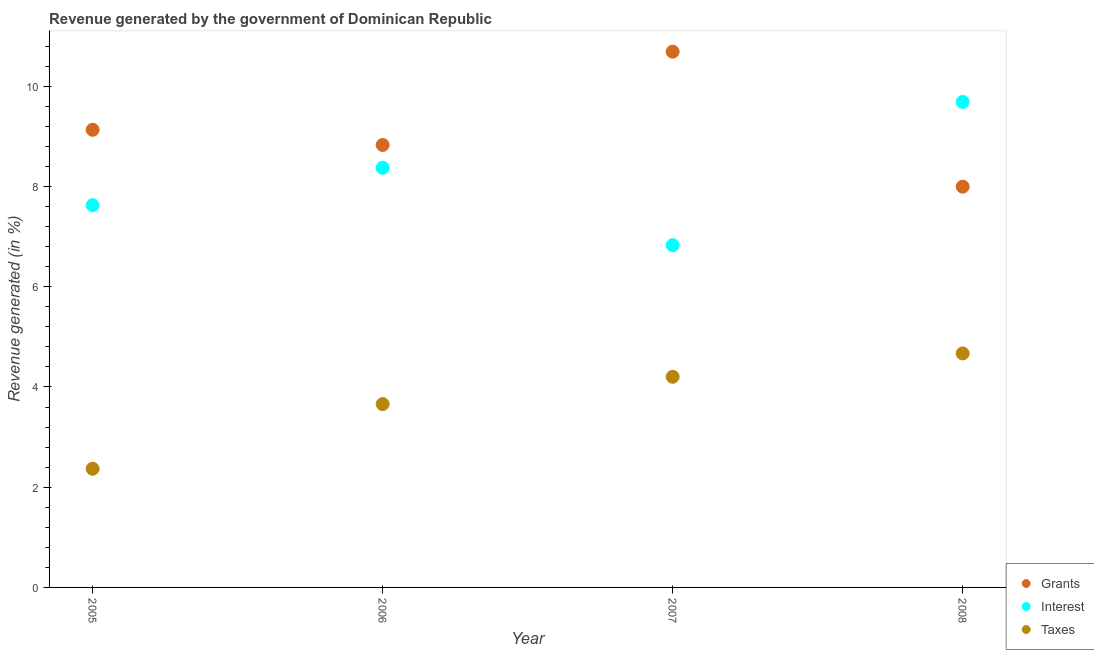How many different coloured dotlines are there?
Your answer should be compact. 3. What is the percentage of revenue generated by interest in 2005?
Provide a short and direct response. 7.63. Across all years, what is the maximum percentage of revenue generated by taxes?
Your response must be concise. 4.67. Across all years, what is the minimum percentage of revenue generated by taxes?
Your answer should be compact. 2.37. In which year was the percentage of revenue generated by grants maximum?
Your answer should be very brief. 2007. In which year was the percentage of revenue generated by taxes minimum?
Keep it short and to the point. 2005. What is the total percentage of revenue generated by taxes in the graph?
Keep it short and to the point. 14.9. What is the difference between the percentage of revenue generated by grants in 2007 and that in 2008?
Make the answer very short. 2.69. What is the difference between the percentage of revenue generated by interest in 2007 and the percentage of revenue generated by grants in 2008?
Make the answer very short. -1.17. What is the average percentage of revenue generated by grants per year?
Offer a very short reply. 9.16. In the year 2008, what is the difference between the percentage of revenue generated by grants and percentage of revenue generated by interest?
Provide a short and direct response. -1.69. In how many years, is the percentage of revenue generated by grants greater than 2.8 %?
Your response must be concise. 4. What is the ratio of the percentage of revenue generated by grants in 2005 to that in 2007?
Give a very brief answer. 0.85. What is the difference between the highest and the second highest percentage of revenue generated by taxes?
Make the answer very short. 0.47. What is the difference between the highest and the lowest percentage of revenue generated by grants?
Your answer should be compact. 2.69. Is the sum of the percentage of revenue generated by interest in 2007 and 2008 greater than the maximum percentage of revenue generated by grants across all years?
Provide a succinct answer. Yes. Is it the case that in every year, the sum of the percentage of revenue generated by grants and percentage of revenue generated by interest is greater than the percentage of revenue generated by taxes?
Ensure brevity in your answer.  Yes. Does the percentage of revenue generated by grants monotonically increase over the years?
Keep it short and to the point. No. Are the values on the major ticks of Y-axis written in scientific E-notation?
Offer a very short reply. No. How many legend labels are there?
Your response must be concise. 3. How are the legend labels stacked?
Offer a very short reply. Vertical. What is the title of the graph?
Your response must be concise. Revenue generated by the government of Dominican Republic. Does "Fuel" appear as one of the legend labels in the graph?
Keep it short and to the point. No. What is the label or title of the Y-axis?
Offer a very short reply. Revenue generated (in %). What is the Revenue generated (in %) of Grants in 2005?
Your response must be concise. 9.13. What is the Revenue generated (in %) in Interest in 2005?
Make the answer very short. 7.63. What is the Revenue generated (in %) of Taxes in 2005?
Offer a very short reply. 2.37. What is the Revenue generated (in %) of Grants in 2006?
Your answer should be compact. 8.83. What is the Revenue generated (in %) in Interest in 2006?
Provide a short and direct response. 8.37. What is the Revenue generated (in %) in Taxes in 2006?
Ensure brevity in your answer.  3.66. What is the Revenue generated (in %) in Grants in 2007?
Offer a terse response. 10.69. What is the Revenue generated (in %) of Interest in 2007?
Ensure brevity in your answer.  6.83. What is the Revenue generated (in %) of Taxes in 2007?
Offer a terse response. 4.2. What is the Revenue generated (in %) of Grants in 2008?
Provide a short and direct response. 8. What is the Revenue generated (in %) of Interest in 2008?
Your answer should be compact. 9.69. What is the Revenue generated (in %) in Taxes in 2008?
Your response must be concise. 4.67. Across all years, what is the maximum Revenue generated (in %) in Grants?
Make the answer very short. 10.69. Across all years, what is the maximum Revenue generated (in %) of Interest?
Your answer should be compact. 9.69. Across all years, what is the maximum Revenue generated (in %) in Taxes?
Give a very brief answer. 4.67. Across all years, what is the minimum Revenue generated (in %) of Grants?
Provide a succinct answer. 8. Across all years, what is the minimum Revenue generated (in %) of Interest?
Provide a succinct answer. 6.83. Across all years, what is the minimum Revenue generated (in %) of Taxes?
Offer a very short reply. 2.37. What is the total Revenue generated (in %) in Grants in the graph?
Your answer should be compact. 36.65. What is the total Revenue generated (in %) in Interest in the graph?
Your answer should be compact. 32.52. What is the total Revenue generated (in %) in Taxes in the graph?
Make the answer very short. 14.9. What is the difference between the Revenue generated (in %) of Grants in 2005 and that in 2006?
Offer a very short reply. 0.3. What is the difference between the Revenue generated (in %) of Interest in 2005 and that in 2006?
Ensure brevity in your answer.  -0.75. What is the difference between the Revenue generated (in %) of Taxes in 2005 and that in 2006?
Your response must be concise. -1.29. What is the difference between the Revenue generated (in %) in Grants in 2005 and that in 2007?
Offer a very short reply. -1.56. What is the difference between the Revenue generated (in %) in Interest in 2005 and that in 2007?
Ensure brevity in your answer.  0.8. What is the difference between the Revenue generated (in %) of Taxes in 2005 and that in 2007?
Give a very brief answer. -1.84. What is the difference between the Revenue generated (in %) in Grants in 2005 and that in 2008?
Make the answer very short. 1.14. What is the difference between the Revenue generated (in %) in Interest in 2005 and that in 2008?
Your answer should be very brief. -2.06. What is the difference between the Revenue generated (in %) of Taxes in 2005 and that in 2008?
Offer a very short reply. -2.3. What is the difference between the Revenue generated (in %) in Grants in 2006 and that in 2007?
Your answer should be compact. -1.86. What is the difference between the Revenue generated (in %) in Interest in 2006 and that in 2007?
Provide a succinct answer. 1.54. What is the difference between the Revenue generated (in %) of Taxes in 2006 and that in 2007?
Offer a terse response. -0.55. What is the difference between the Revenue generated (in %) in Grants in 2006 and that in 2008?
Ensure brevity in your answer.  0.83. What is the difference between the Revenue generated (in %) of Interest in 2006 and that in 2008?
Your response must be concise. -1.31. What is the difference between the Revenue generated (in %) in Taxes in 2006 and that in 2008?
Give a very brief answer. -1.01. What is the difference between the Revenue generated (in %) of Grants in 2007 and that in 2008?
Keep it short and to the point. 2.69. What is the difference between the Revenue generated (in %) of Interest in 2007 and that in 2008?
Provide a succinct answer. -2.86. What is the difference between the Revenue generated (in %) in Taxes in 2007 and that in 2008?
Offer a terse response. -0.47. What is the difference between the Revenue generated (in %) of Grants in 2005 and the Revenue generated (in %) of Interest in 2006?
Provide a succinct answer. 0.76. What is the difference between the Revenue generated (in %) of Grants in 2005 and the Revenue generated (in %) of Taxes in 2006?
Offer a terse response. 5.47. What is the difference between the Revenue generated (in %) in Interest in 2005 and the Revenue generated (in %) in Taxes in 2006?
Offer a very short reply. 3.97. What is the difference between the Revenue generated (in %) of Grants in 2005 and the Revenue generated (in %) of Interest in 2007?
Your answer should be compact. 2.3. What is the difference between the Revenue generated (in %) in Grants in 2005 and the Revenue generated (in %) in Taxes in 2007?
Give a very brief answer. 4.93. What is the difference between the Revenue generated (in %) of Interest in 2005 and the Revenue generated (in %) of Taxes in 2007?
Your answer should be very brief. 3.42. What is the difference between the Revenue generated (in %) in Grants in 2005 and the Revenue generated (in %) in Interest in 2008?
Your answer should be very brief. -0.56. What is the difference between the Revenue generated (in %) in Grants in 2005 and the Revenue generated (in %) in Taxes in 2008?
Your response must be concise. 4.46. What is the difference between the Revenue generated (in %) in Interest in 2005 and the Revenue generated (in %) in Taxes in 2008?
Your answer should be compact. 2.96. What is the difference between the Revenue generated (in %) in Grants in 2006 and the Revenue generated (in %) in Interest in 2007?
Give a very brief answer. 2. What is the difference between the Revenue generated (in %) in Grants in 2006 and the Revenue generated (in %) in Taxes in 2007?
Make the answer very short. 4.63. What is the difference between the Revenue generated (in %) of Interest in 2006 and the Revenue generated (in %) of Taxes in 2007?
Offer a very short reply. 4.17. What is the difference between the Revenue generated (in %) in Grants in 2006 and the Revenue generated (in %) in Interest in 2008?
Keep it short and to the point. -0.86. What is the difference between the Revenue generated (in %) in Grants in 2006 and the Revenue generated (in %) in Taxes in 2008?
Provide a short and direct response. 4.16. What is the difference between the Revenue generated (in %) of Interest in 2006 and the Revenue generated (in %) of Taxes in 2008?
Your answer should be compact. 3.7. What is the difference between the Revenue generated (in %) of Grants in 2007 and the Revenue generated (in %) of Taxes in 2008?
Ensure brevity in your answer.  6.02. What is the difference between the Revenue generated (in %) of Interest in 2007 and the Revenue generated (in %) of Taxes in 2008?
Offer a very short reply. 2.16. What is the average Revenue generated (in %) in Grants per year?
Make the answer very short. 9.16. What is the average Revenue generated (in %) in Interest per year?
Make the answer very short. 8.13. What is the average Revenue generated (in %) of Taxes per year?
Provide a short and direct response. 3.72. In the year 2005, what is the difference between the Revenue generated (in %) of Grants and Revenue generated (in %) of Interest?
Provide a short and direct response. 1.5. In the year 2005, what is the difference between the Revenue generated (in %) in Grants and Revenue generated (in %) in Taxes?
Provide a short and direct response. 6.76. In the year 2005, what is the difference between the Revenue generated (in %) of Interest and Revenue generated (in %) of Taxes?
Ensure brevity in your answer.  5.26. In the year 2006, what is the difference between the Revenue generated (in %) in Grants and Revenue generated (in %) in Interest?
Your response must be concise. 0.46. In the year 2006, what is the difference between the Revenue generated (in %) in Grants and Revenue generated (in %) in Taxes?
Offer a terse response. 5.17. In the year 2006, what is the difference between the Revenue generated (in %) of Interest and Revenue generated (in %) of Taxes?
Your answer should be very brief. 4.72. In the year 2007, what is the difference between the Revenue generated (in %) of Grants and Revenue generated (in %) of Interest?
Offer a terse response. 3.86. In the year 2007, what is the difference between the Revenue generated (in %) in Grants and Revenue generated (in %) in Taxes?
Give a very brief answer. 6.49. In the year 2007, what is the difference between the Revenue generated (in %) in Interest and Revenue generated (in %) in Taxes?
Offer a very short reply. 2.63. In the year 2008, what is the difference between the Revenue generated (in %) of Grants and Revenue generated (in %) of Interest?
Your answer should be compact. -1.69. In the year 2008, what is the difference between the Revenue generated (in %) of Grants and Revenue generated (in %) of Taxes?
Provide a short and direct response. 3.33. In the year 2008, what is the difference between the Revenue generated (in %) in Interest and Revenue generated (in %) in Taxes?
Keep it short and to the point. 5.02. What is the ratio of the Revenue generated (in %) of Grants in 2005 to that in 2006?
Your answer should be very brief. 1.03. What is the ratio of the Revenue generated (in %) in Interest in 2005 to that in 2006?
Provide a succinct answer. 0.91. What is the ratio of the Revenue generated (in %) in Taxes in 2005 to that in 2006?
Provide a succinct answer. 0.65. What is the ratio of the Revenue generated (in %) of Grants in 2005 to that in 2007?
Offer a very short reply. 0.85. What is the ratio of the Revenue generated (in %) in Interest in 2005 to that in 2007?
Keep it short and to the point. 1.12. What is the ratio of the Revenue generated (in %) of Taxes in 2005 to that in 2007?
Your answer should be very brief. 0.56. What is the ratio of the Revenue generated (in %) of Grants in 2005 to that in 2008?
Give a very brief answer. 1.14. What is the ratio of the Revenue generated (in %) of Interest in 2005 to that in 2008?
Your answer should be very brief. 0.79. What is the ratio of the Revenue generated (in %) of Taxes in 2005 to that in 2008?
Provide a short and direct response. 0.51. What is the ratio of the Revenue generated (in %) of Grants in 2006 to that in 2007?
Keep it short and to the point. 0.83. What is the ratio of the Revenue generated (in %) of Interest in 2006 to that in 2007?
Provide a short and direct response. 1.23. What is the ratio of the Revenue generated (in %) in Taxes in 2006 to that in 2007?
Your response must be concise. 0.87. What is the ratio of the Revenue generated (in %) of Grants in 2006 to that in 2008?
Give a very brief answer. 1.1. What is the ratio of the Revenue generated (in %) in Interest in 2006 to that in 2008?
Provide a short and direct response. 0.86. What is the ratio of the Revenue generated (in %) in Taxes in 2006 to that in 2008?
Offer a terse response. 0.78. What is the ratio of the Revenue generated (in %) in Grants in 2007 to that in 2008?
Your response must be concise. 1.34. What is the ratio of the Revenue generated (in %) of Interest in 2007 to that in 2008?
Offer a terse response. 0.7. What is the ratio of the Revenue generated (in %) in Taxes in 2007 to that in 2008?
Provide a succinct answer. 0.9. What is the difference between the highest and the second highest Revenue generated (in %) in Grants?
Offer a terse response. 1.56. What is the difference between the highest and the second highest Revenue generated (in %) in Interest?
Provide a succinct answer. 1.31. What is the difference between the highest and the second highest Revenue generated (in %) in Taxes?
Your response must be concise. 0.47. What is the difference between the highest and the lowest Revenue generated (in %) of Grants?
Your answer should be very brief. 2.69. What is the difference between the highest and the lowest Revenue generated (in %) in Interest?
Your response must be concise. 2.86. What is the difference between the highest and the lowest Revenue generated (in %) of Taxes?
Offer a terse response. 2.3. 